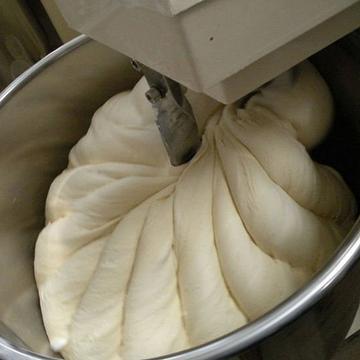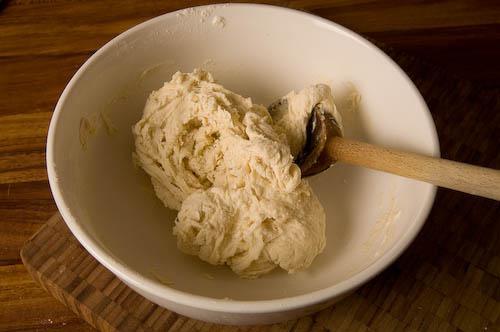The first image is the image on the left, the second image is the image on the right. For the images shown, is this caption "Only one wooden spoon is visible." true? Answer yes or no. Yes. The first image is the image on the left, the second image is the image on the right. Examine the images to the left and right. Is the description "In one of the images, the dough is being stirred by a mixer." accurate? Answer yes or no. Yes. 